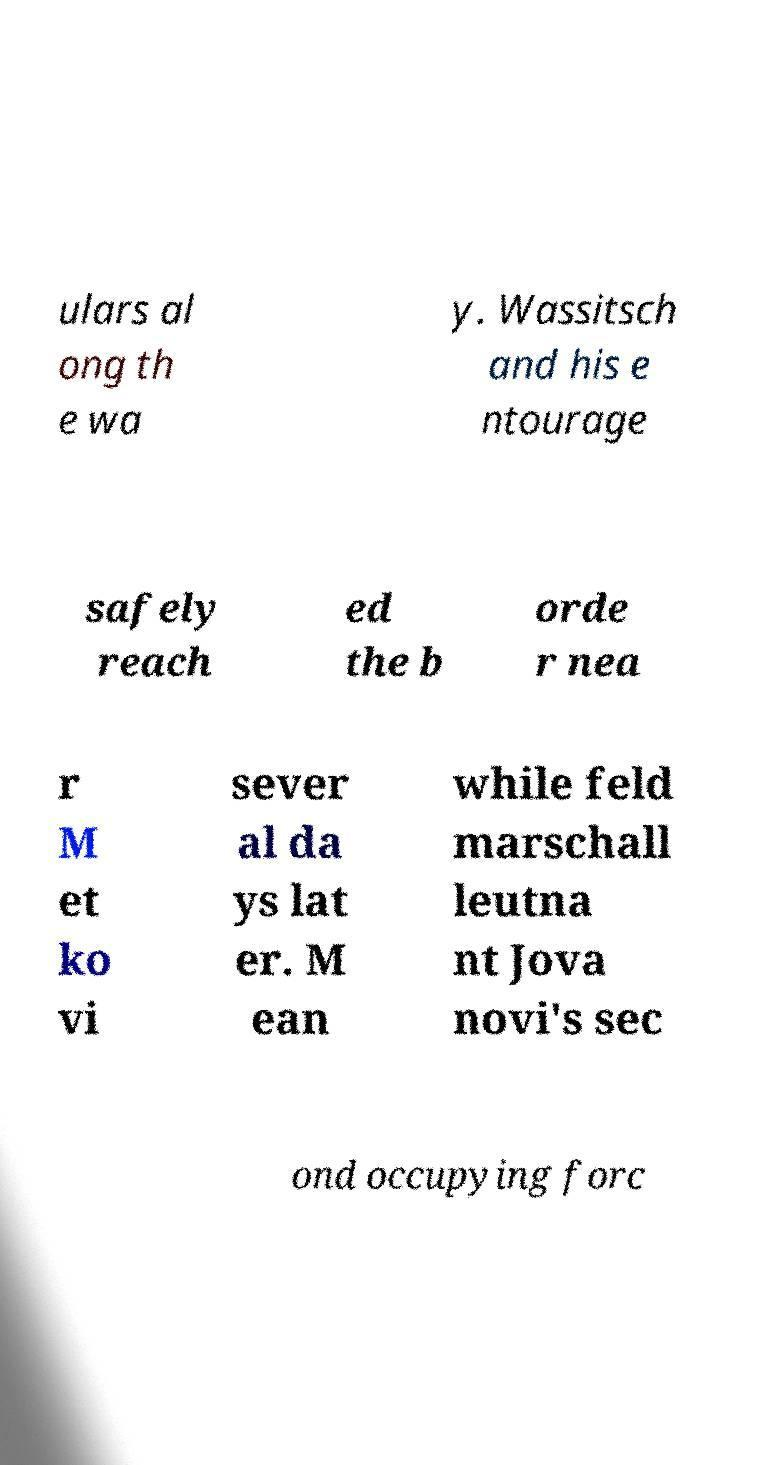Can you accurately transcribe the text from the provided image for me? ulars al ong th e wa y. Wassitsch and his e ntourage safely reach ed the b orde r nea r M et ko vi sever al da ys lat er. M ean while feld marschall leutna nt Jova novi's sec ond occupying forc 